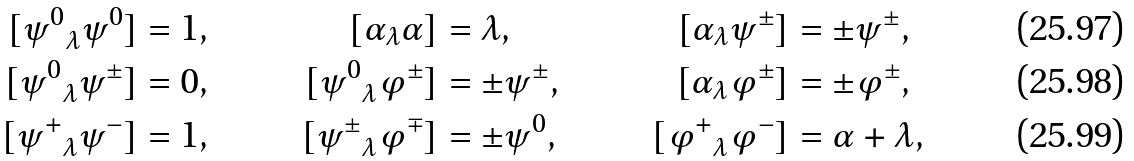<formula> <loc_0><loc_0><loc_500><loc_500>{ [ \psi ^ { 0 } } _ { \lambda } \psi ^ { 0 } ] & = 1 , & [ \alpha _ { \lambda } \alpha ] & = \lambda , & [ \alpha _ { \lambda } \psi ^ { \pm } ] & = \pm \psi ^ { \pm } , \\ { [ \psi ^ { 0 } } _ { \lambda } \psi ^ { \pm } ] & = 0 , & { [ \psi ^ { 0 } } _ { \lambda } \varphi ^ { \pm } ] & = \pm \psi ^ { \pm } , & [ \alpha _ { \lambda } \varphi ^ { \pm } ] & = \pm \varphi ^ { \pm } , \\ { [ \psi ^ { + } } _ { \lambda } \psi ^ { - } ] & = 1 , & { [ \psi ^ { \pm } } _ { \lambda } \varphi ^ { \mp } ] & = \pm \psi ^ { 0 } , & { [ \varphi ^ { + } } _ { \lambda } \varphi ^ { - } ] & = \alpha + \lambda ,</formula> 